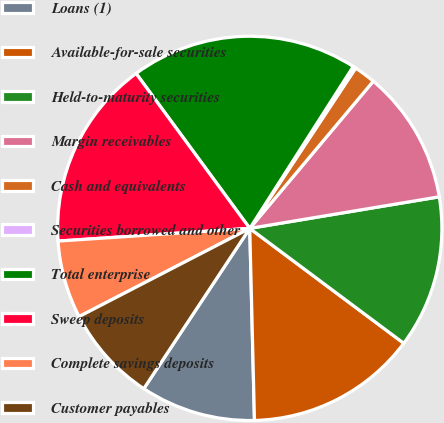Convert chart to OTSL. <chart><loc_0><loc_0><loc_500><loc_500><pie_chart><fcel>Loans (1)<fcel>Available-for-sale securities<fcel>Held-to-maturity securities<fcel>Margin receivables<fcel>Cash and equivalents<fcel>Securities borrowed and other<fcel>Total enterprise<fcel>Sweep deposits<fcel>Complete savings deposits<fcel>Customer payables<nl><fcel>9.69%<fcel>14.41%<fcel>12.83%<fcel>11.26%<fcel>1.82%<fcel>0.24%<fcel>19.13%<fcel>15.98%<fcel>6.54%<fcel>8.11%<nl></chart> 